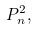Convert formula to latex. <formula><loc_0><loc_0><loc_500><loc_500>P _ { n } ^ { 2 } ,</formula> 